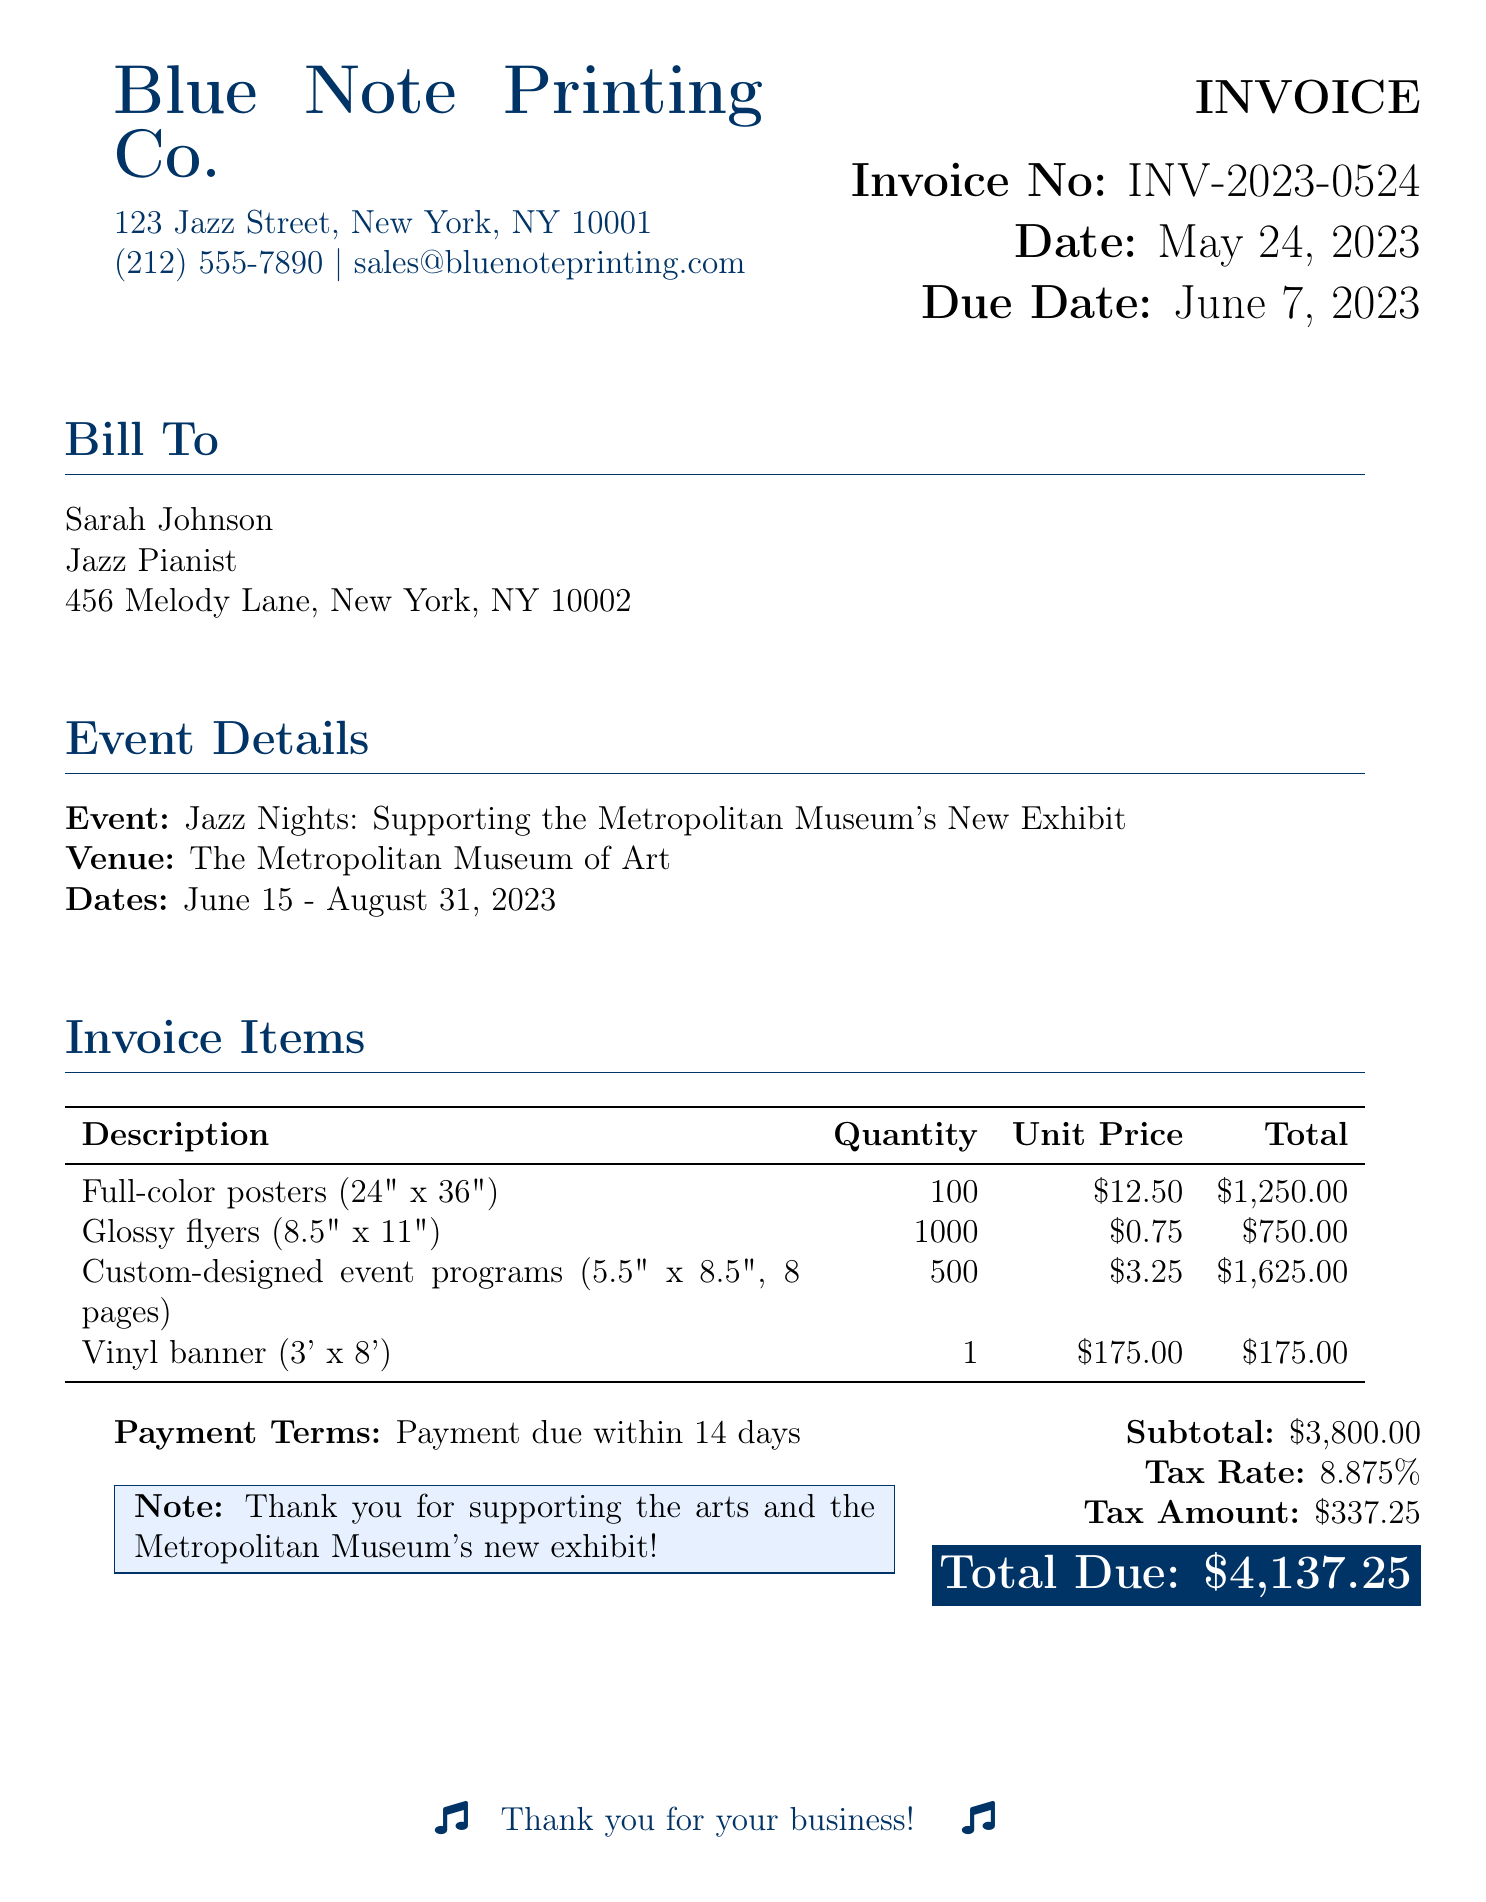What is the name of the printing company? The name of the printing company is listed at the top of the document as "Blue Note Printing Co."
Answer: Blue Note Printing Co What is the total amount due? The total amount due is stated in bold at the bottom of the invoice.
Answer: $4,137.25 What is the venue for the performance series? The venue for the event is specified in the "Event Details" section.
Answer: The Metropolitan Museum of Art How many full-color posters are being ordered? The quantity of full-color posters is indicated in the invoice items table.
Answer: 100 What is the due date for the payment? The due date for payment is provided in the invoice details section.
Answer: June 7, 2023 What percentage is the tax rate mentioned in the bill? The tax rate is explicitly stated within the financial details of the document.
Answer: 8.875% Which item on the invoice has the highest total cost? The item with the highest total cost is identified in the invoice items table.
Answer: Custom-designed event programs What is the total quantity of glossy flyers ordered? The total quantity of glossy flyers is listed in the invoice items section.
Answer: 1000 